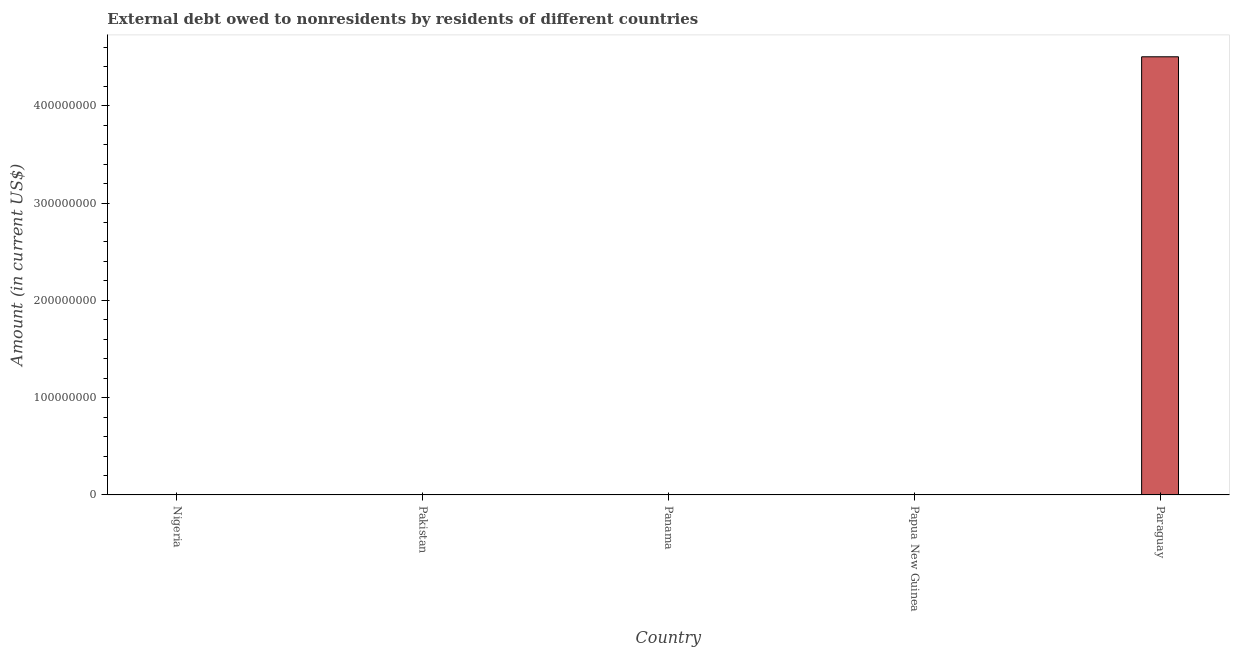Does the graph contain any zero values?
Offer a terse response. Yes. What is the title of the graph?
Ensure brevity in your answer.  External debt owed to nonresidents by residents of different countries. What is the label or title of the Y-axis?
Ensure brevity in your answer.  Amount (in current US$). Across all countries, what is the maximum debt?
Your answer should be very brief. 4.50e+08. Across all countries, what is the minimum debt?
Keep it short and to the point. 0. In which country was the debt maximum?
Offer a terse response. Paraguay. What is the sum of the debt?
Your answer should be very brief. 4.50e+08. What is the average debt per country?
Keep it short and to the point. 9.01e+07. What is the median debt?
Your answer should be very brief. 0. In how many countries, is the debt greater than 120000000 US$?
Your answer should be very brief. 1. What is the difference between the highest and the lowest debt?
Keep it short and to the point. 4.50e+08. In how many countries, is the debt greater than the average debt taken over all countries?
Your response must be concise. 1. Are all the bars in the graph horizontal?
Ensure brevity in your answer.  No. What is the difference between two consecutive major ticks on the Y-axis?
Keep it short and to the point. 1.00e+08. What is the Amount (in current US$) in Pakistan?
Your answer should be very brief. 0. What is the Amount (in current US$) of Panama?
Provide a succinct answer. 0. What is the Amount (in current US$) of Papua New Guinea?
Offer a terse response. 0. What is the Amount (in current US$) in Paraguay?
Offer a terse response. 4.50e+08. 